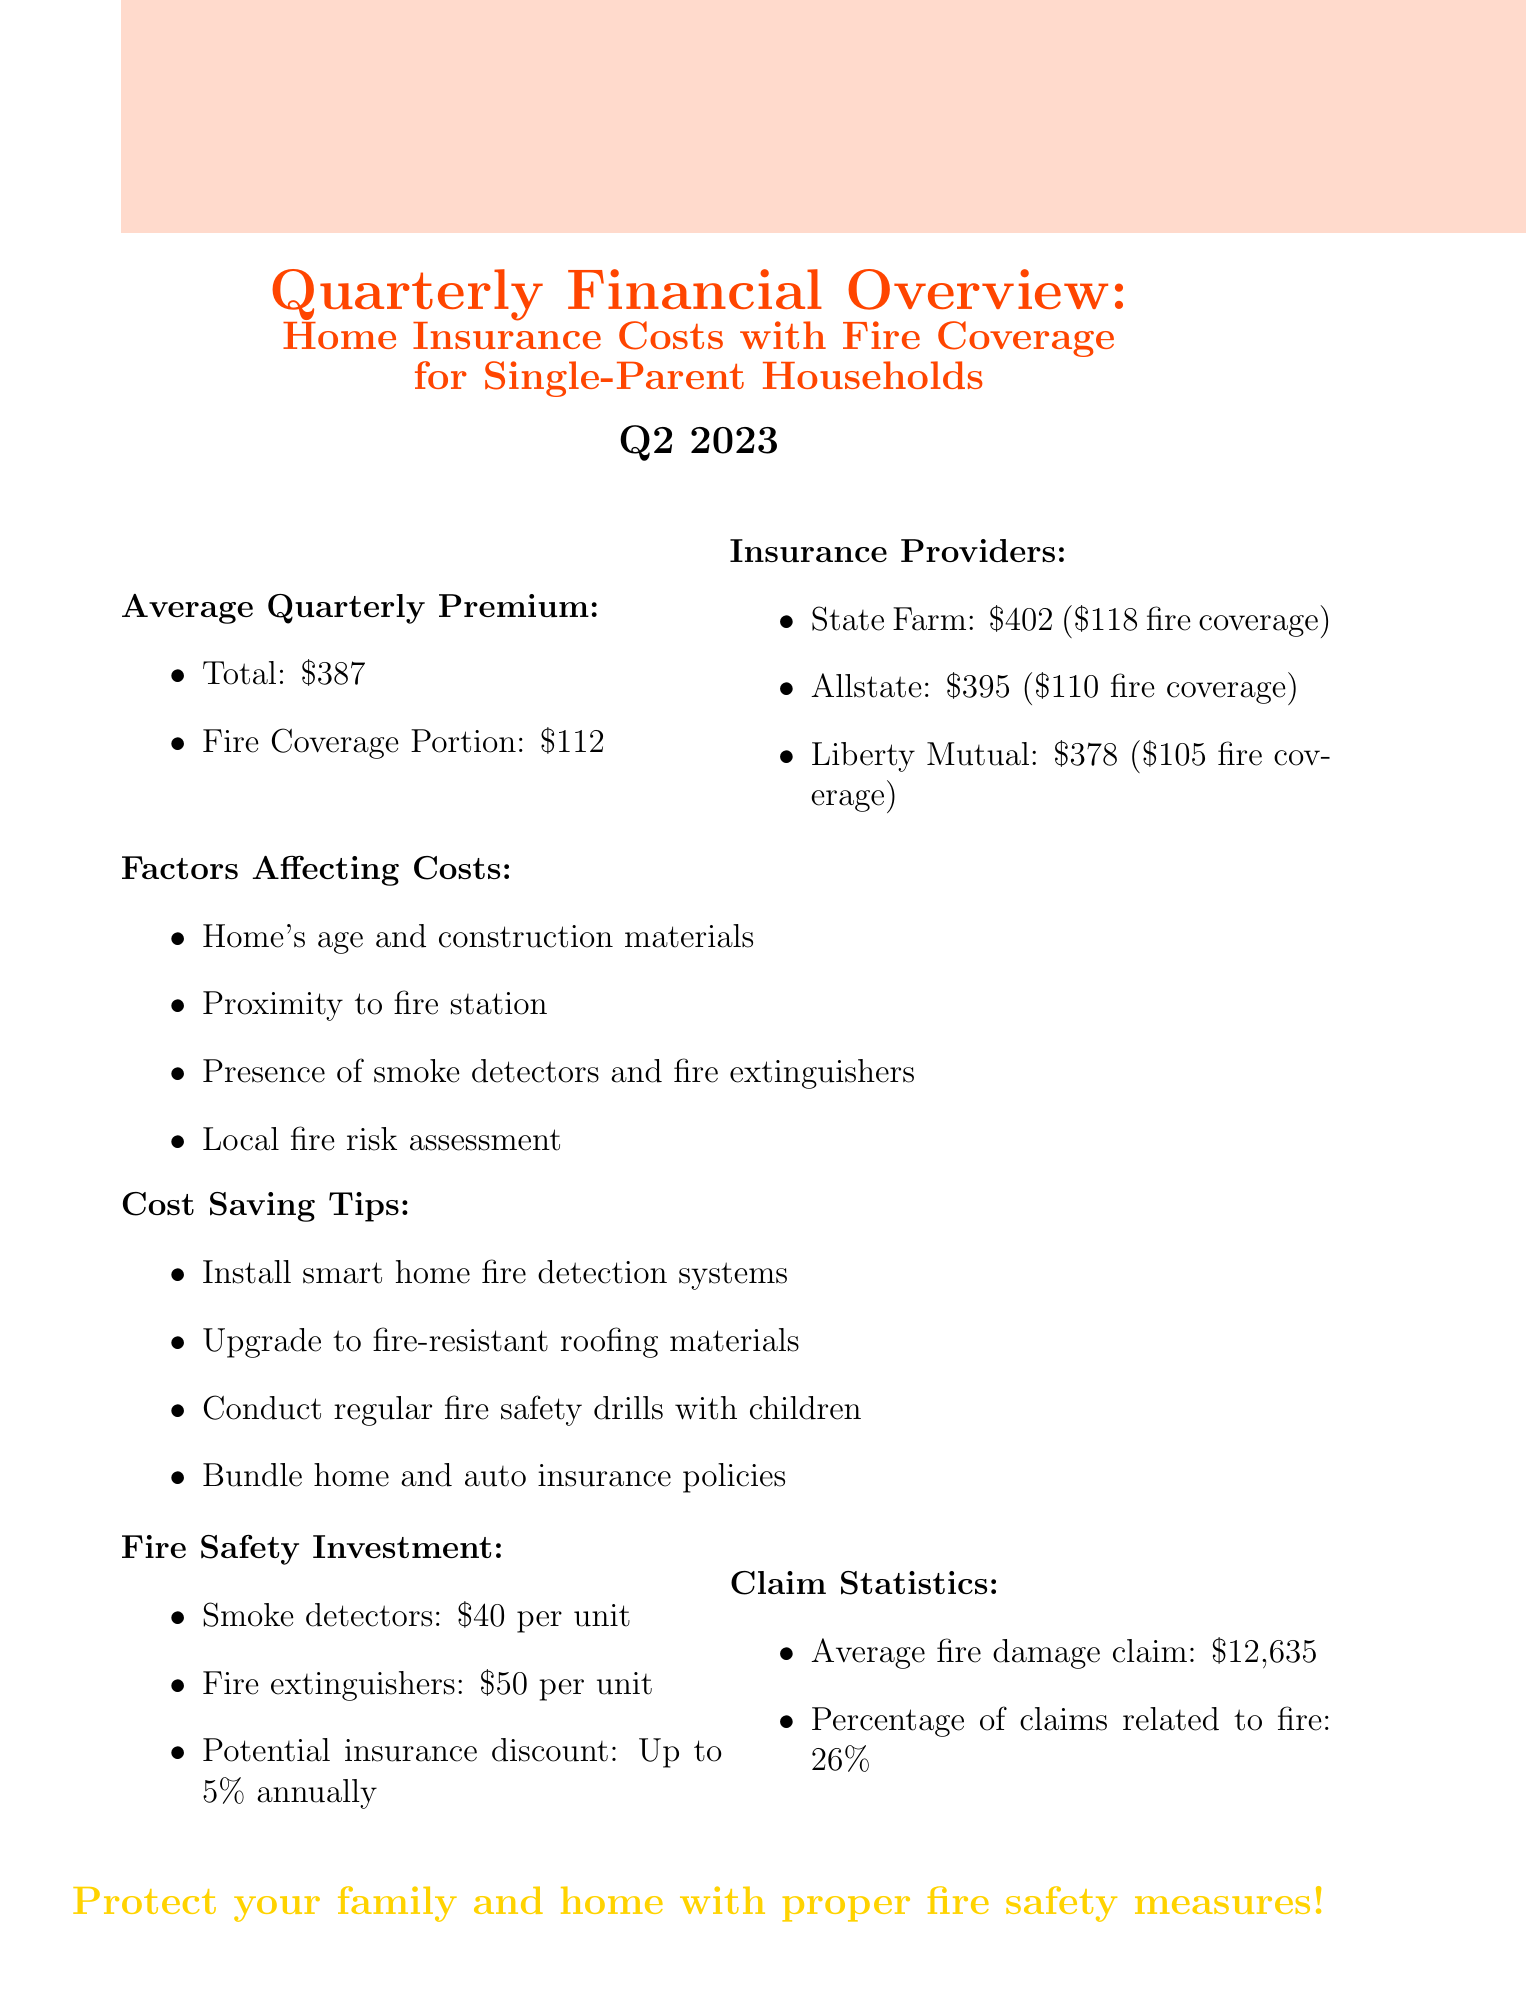What is the average quarterly premium? The average quarterly premium is stated in the document as $387.
Answer: $387 How much is the fire coverage portion of the average quarterly premium? The document specifies that the fire coverage portion is $112.
Answer: $112 Which insurance provider has the highest quarterly premium? State Farm has the highest quarterly premium listed at $402.
Answer: State Farm What percentage of claims are related to fire? The document states that 26% of claims are related to fire.
Answer: 26% What is the potential insurance discount for fire safety investments? The document indicates a potential insurance discount of up to 5% annually.
Answer: Up to 5% annually What are two factors affecting home insurance costs mentioned in the document? The document lists several factors, including the home's age and construction materials, and proximity to fire station.
Answer: Home's age and construction materials, proximity to fire station What is the average fire damage claim amount? The average fire damage claim amount is provided as $12,635 in the document.
Answer: $12,635 List one cost-saving tip provided in the document. The document suggests installing smart home fire detection systems as a cost-saving tip.
Answer: Install smart home fire detection systems 